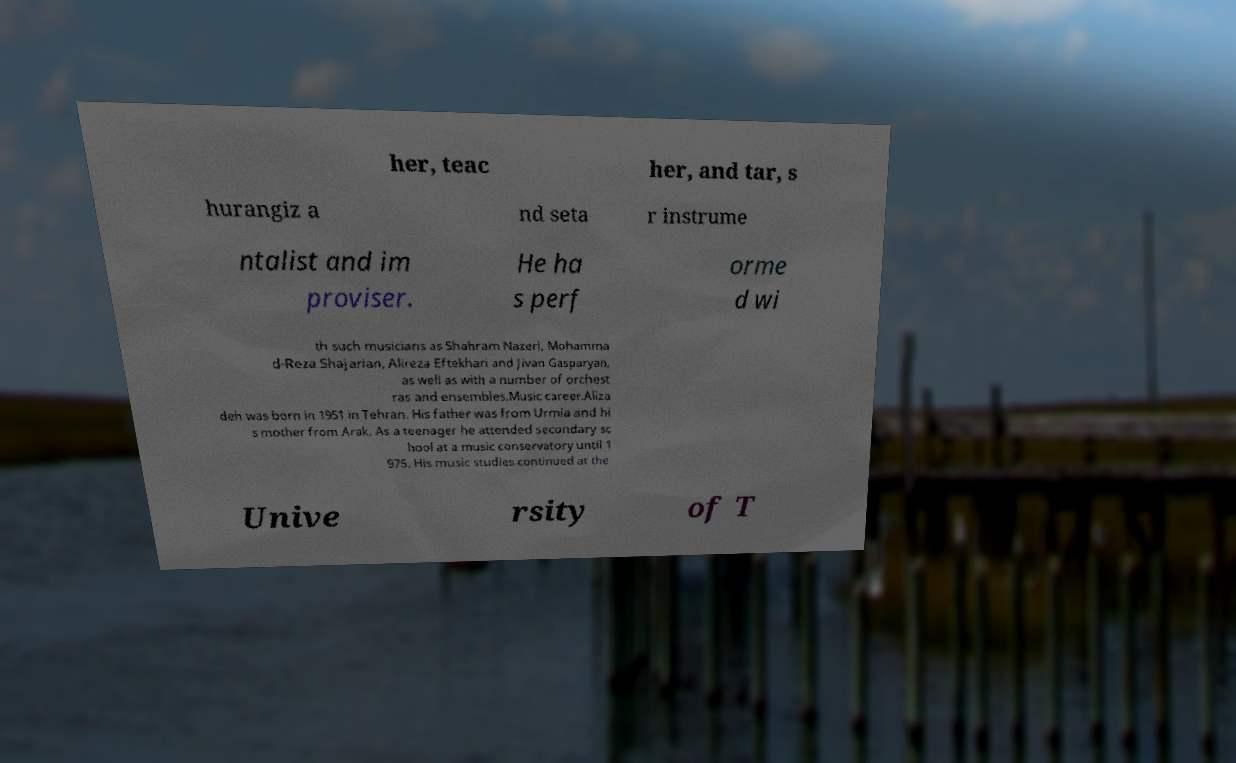Could you extract and type out the text from this image? her, teac her, and tar, s hurangiz a nd seta r instrume ntalist and im proviser. He ha s perf orme d wi th such musicians as Shahram Nazeri, Mohamma d-Reza Shajarian, Alireza Eftekhari and Jivan Gasparyan, as well as with a number of orchest ras and ensembles.Music career.Aliza deh was born in 1951 in Tehran. His father was from Urmia and hi s mother from Arak. As a teenager he attended secondary sc hool at a music conservatory until 1 975. His music studies continued at the Unive rsity of T 